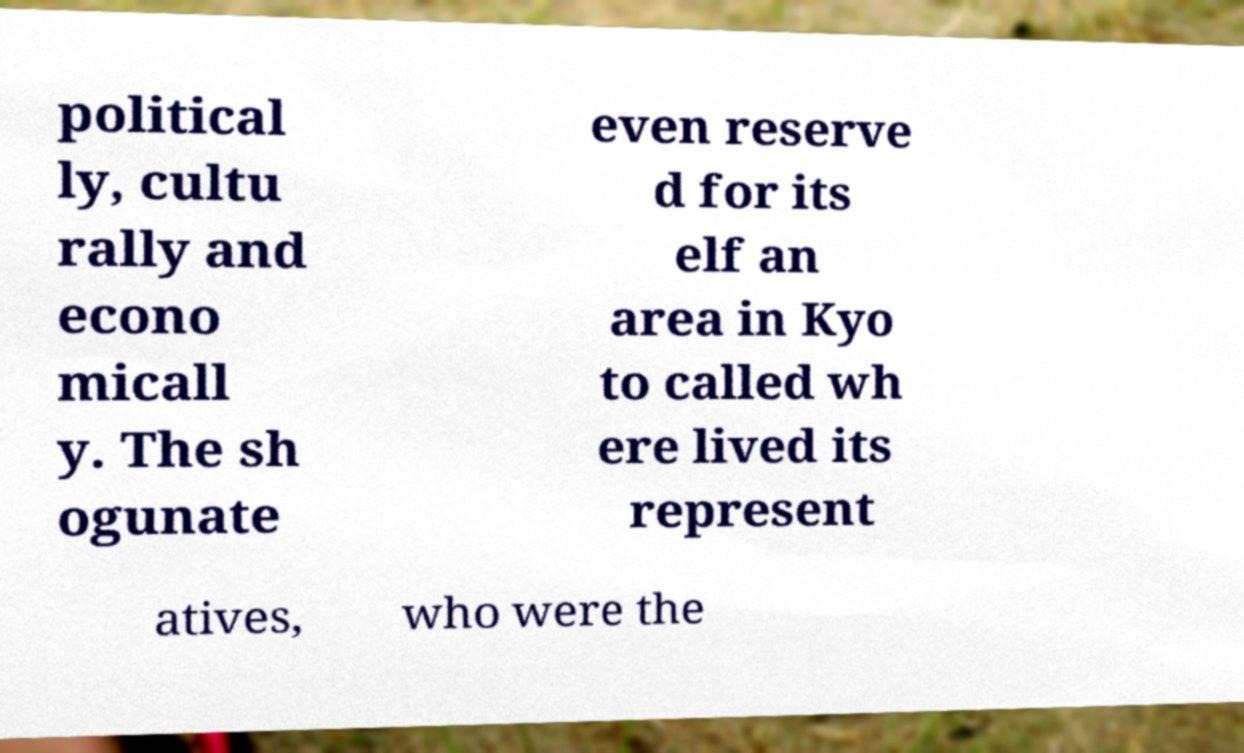There's text embedded in this image that I need extracted. Can you transcribe it verbatim? political ly, cultu rally and econo micall y. The sh ogunate even reserve d for its elf an area in Kyo to called wh ere lived its represent atives, who were the 